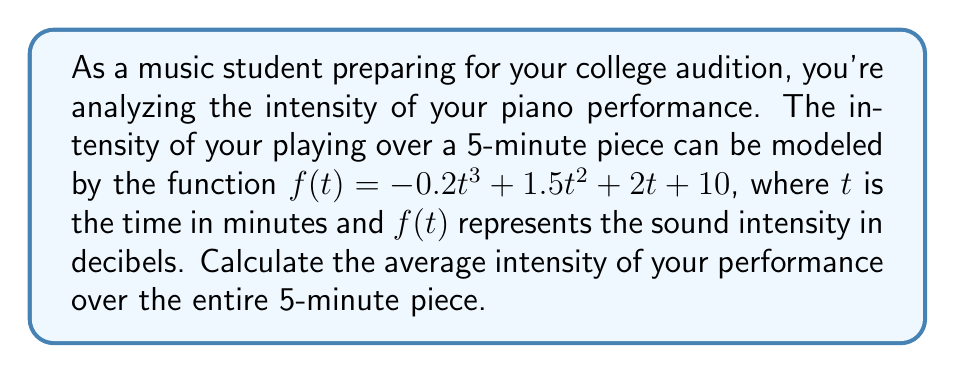Show me your answer to this math problem. To find the average intensity, we need to:
1) Calculate the total intensity over the 5-minute period (area under the curve)
2) Divide this total by the time period (5 minutes)

Step 1: Calculate the area under the curve
The area under the curve is given by the definite integral of $f(t)$ from $t=0$ to $t=5$:

$$\int_0^5 (-0.2t^3 + 1.5t^2 + 2t + 10) dt$$

Let's integrate term by term:

$$\begin{align*}
&\int_0^5 -0.2t^3 dt &= -0.05t^4 \bigg|_0^5 \\
&\int_0^5 1.5t^2 dt &= 0.5t^3 \bigg|_0^5 \\
&\int_0^5 2t dt &= t^2 \bigg|_0^5 \\
&\int_0^5 10 dt &= 10t \bigg|_0^5
\end{align*}$$

Now, let's evaluate each term:

$$\begin{align*}
-0.05(5^4 - 0^4) &= -31.25 \\
0.5(5^3 - 0^3) &= 62.5 \\
5^2 - 0^2 &= 25 \\
10(5 - 0) &= 50
\end{align*}$$

Sum these results:
$-31.25 + 62.5 + 25 + 50 = 106.25$

Step 2: Calculate the average
Average intensity = Total intensity / Time period
$$ \text{Average Intensity} = \frac{106.25}{5} = 21.25 \text{ decibels} $$
Answer: The average intensity of the performance over the 5-minute piece is 21.25 decibels. 